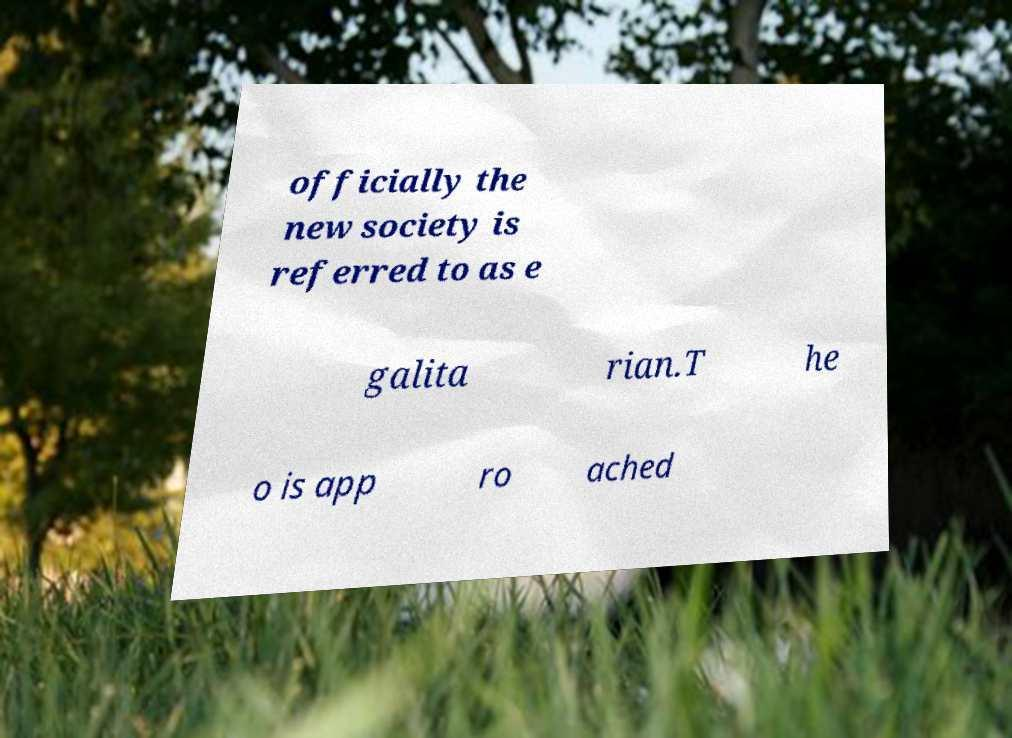For documentation purposes, I need the text within this image transcribed. Could you provide that? officially the new society is referred to as e galita rian.T he o is app ro ached 